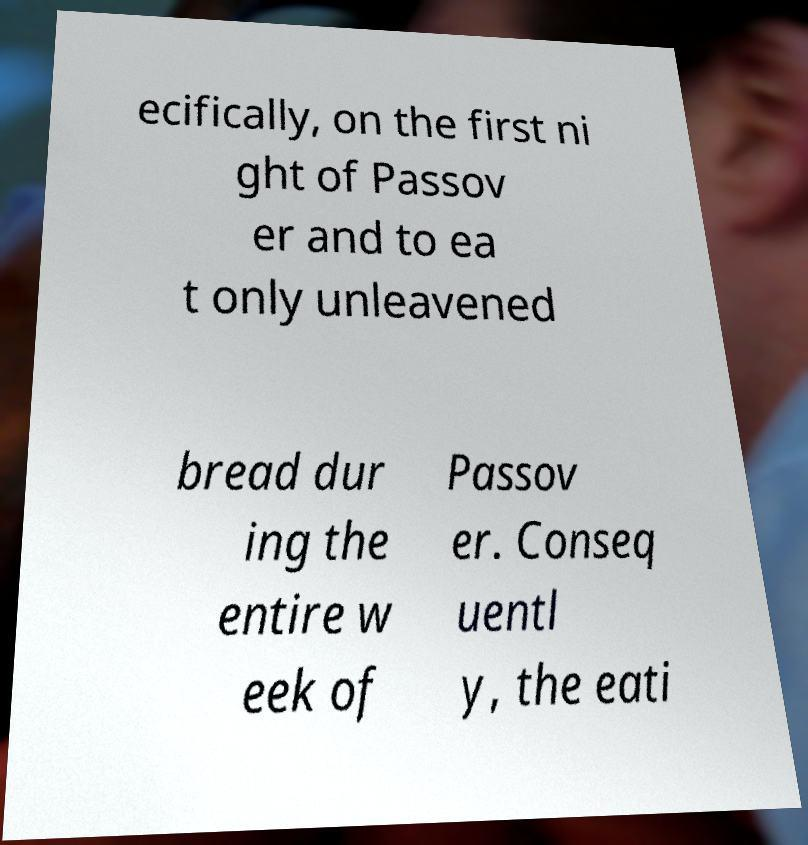Please read and relay the text visible in this image. What does it say? ecifically, on the first ni ght of Passov er and to ea t only unleavened bread dur ing the entire w eek of Passov er. Conseq uentl y, the eati 